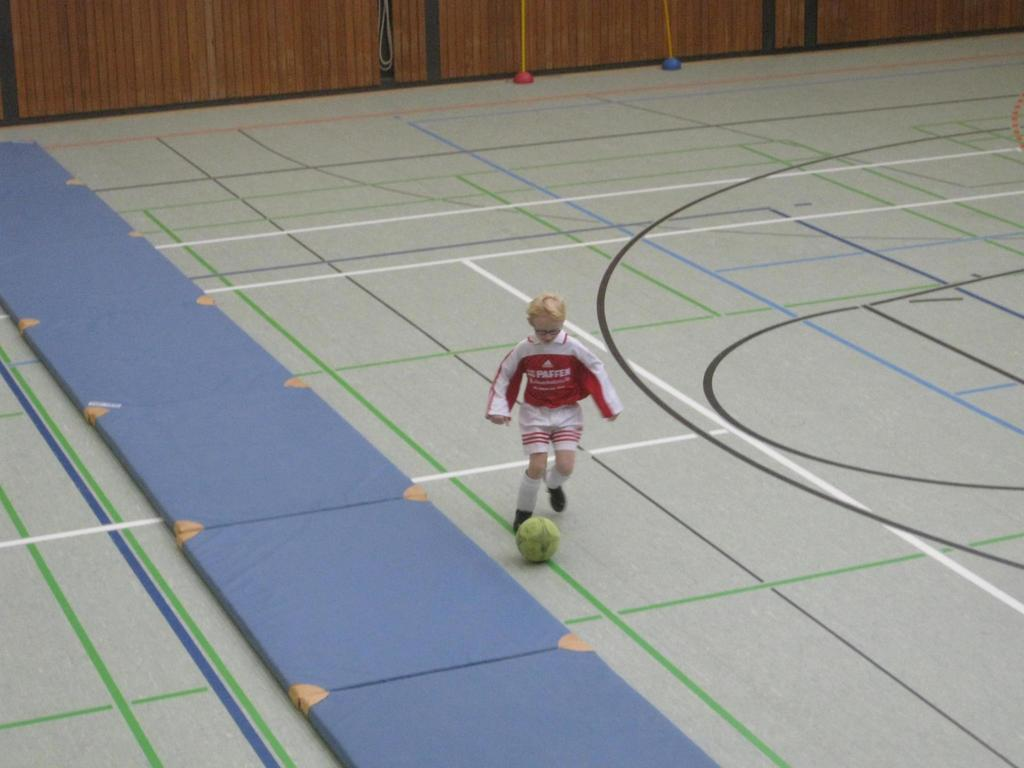<image>
Provide a brief description of the given image. A little boy that is wearing a shirt that says Paffer and he's kicking a ball 